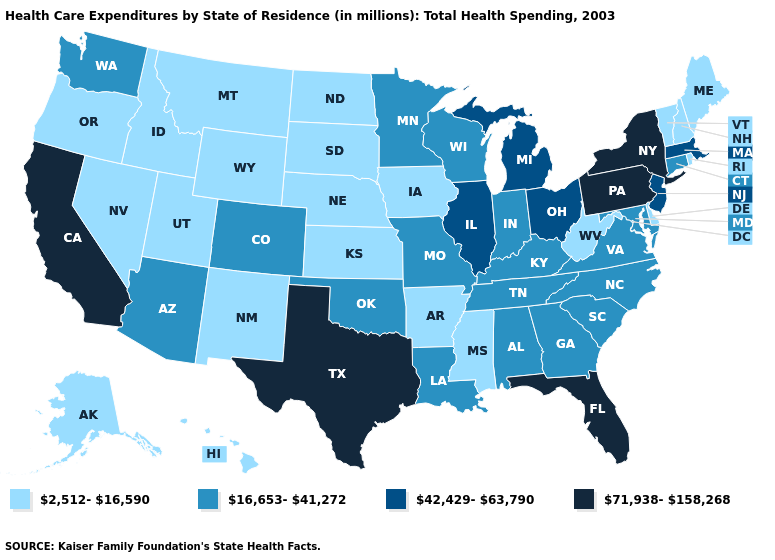What is the lowest value in states that border Texas?
Give a very brief answer. 2,512-16,590. Among the states that border Maine , which have the highest value?
Concise answer only. New Hampshire. Name the states that have a value in the range 42,429-63,790?
Write a very short answer. Illinois, Massachusetts, Michigan, New Jersey, Ohio. What is the highest value in states that border Kansas?
Write a very short answer. 16,653-41,272. Does Iowa have a lower value than Idaho?
Answer briefly. No. What is the value of Missouri?
Answer briefly. 16,653-41,272. Name the states that have a value in the range 42,429-63,790?
Be succinct. Illinois, Massachusetts, Michigan, New Jersey, Ohio. What is the value of Nevada?
Keep it brief. 2,512-16,590. Does Nebraska have the highest value in the USA?
Concise answer only. No. What is the highest value in the USA?
Concise answer only. 71,938-158,268. What is the value of Nevada?
Quick response, please. 2,512-16,590. Does the map have missing data?
Write a very short answer. No. What is the lowest value in the West?
Answer briefly. 2,512-16,590. Which states have the lowest value in the USA?
Answer briefly. Alaska, Arkansas, Delaware, Hawaii, Idaho, Iowa, Kansas, Maine, Mississippi, Montana, Nebraska, Nevada, New Hampshire, New Mexico, North Dakota, Oregon, Rhode Island, South Dakota, Utah, Vermont, West Virginia, Wyoming. Which states have the lowest value in the West?
Write a very short answer. Alaska, Hawaii, Idaho, Montana, Nevada, New Mexico, Oregon, Utah, Wyoming. 